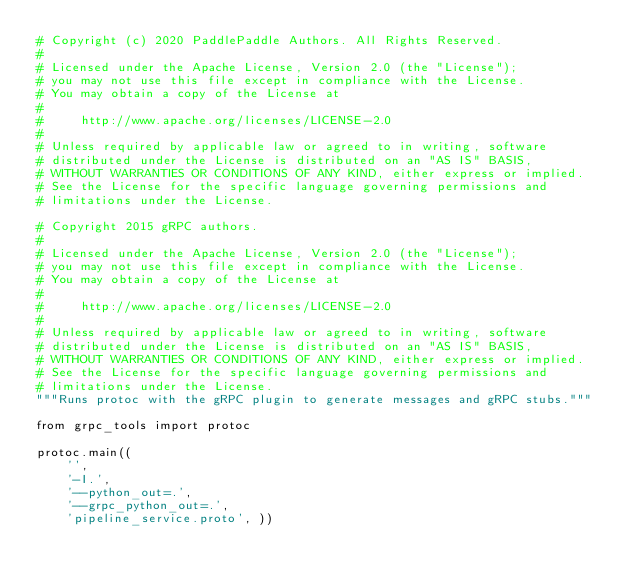<code> <loc_0><loc_0><loc_500><loc_500><_Python_># Copyright (c) 2020 PaddlePaddle Authors. All Rights Reserved.
#
# Licensed under the Apache License, Version 2.0 (the "License");
# you may not use this file except in compliance with the License.
# You may obtain a copy of the License at
#
#     http://www.apache.org/licenses/LICENSE-2.0
#
# Unless required by applicable law or agreed to in writing, software
# distributed under the License is distributed on an "AS IS" BASIS,
# WITHOUT WARRANTIES OR CONDITIONS OF ANY KIND, either express or implied.
# See the License for the specific language governing permissions and
# limitations under the License.

# Copyright 2015 gRPC authors.
#
# Licensed under the Apache License, Version 2.0 (the "License");
# you may not use this file except in compliance with the License.
# You may obtain a copy of the License at
#
#     http://www.apache.org/licenses/LICENSE-2.0
#
# Unless required by applicable law or agreed to in writing, software
# distributed under the License is distributed on an "AS IS" BASIS,
# WITHOUT WARRANTIES OR CONDITIONS OF ANY KIND, either express or implied.
# See the License for the specific language governing permissions and
# limitations under the License.
"""Runs protoc with the gRPC plugin to generate messages and gRPC stubs."""

from grpc_tools import protoc

protoc.main((
    '',
    '-I.',
    '--python_out=.',
    '--grpc_python_out=.',
    'pipeline_service.proto', ))
</code> 